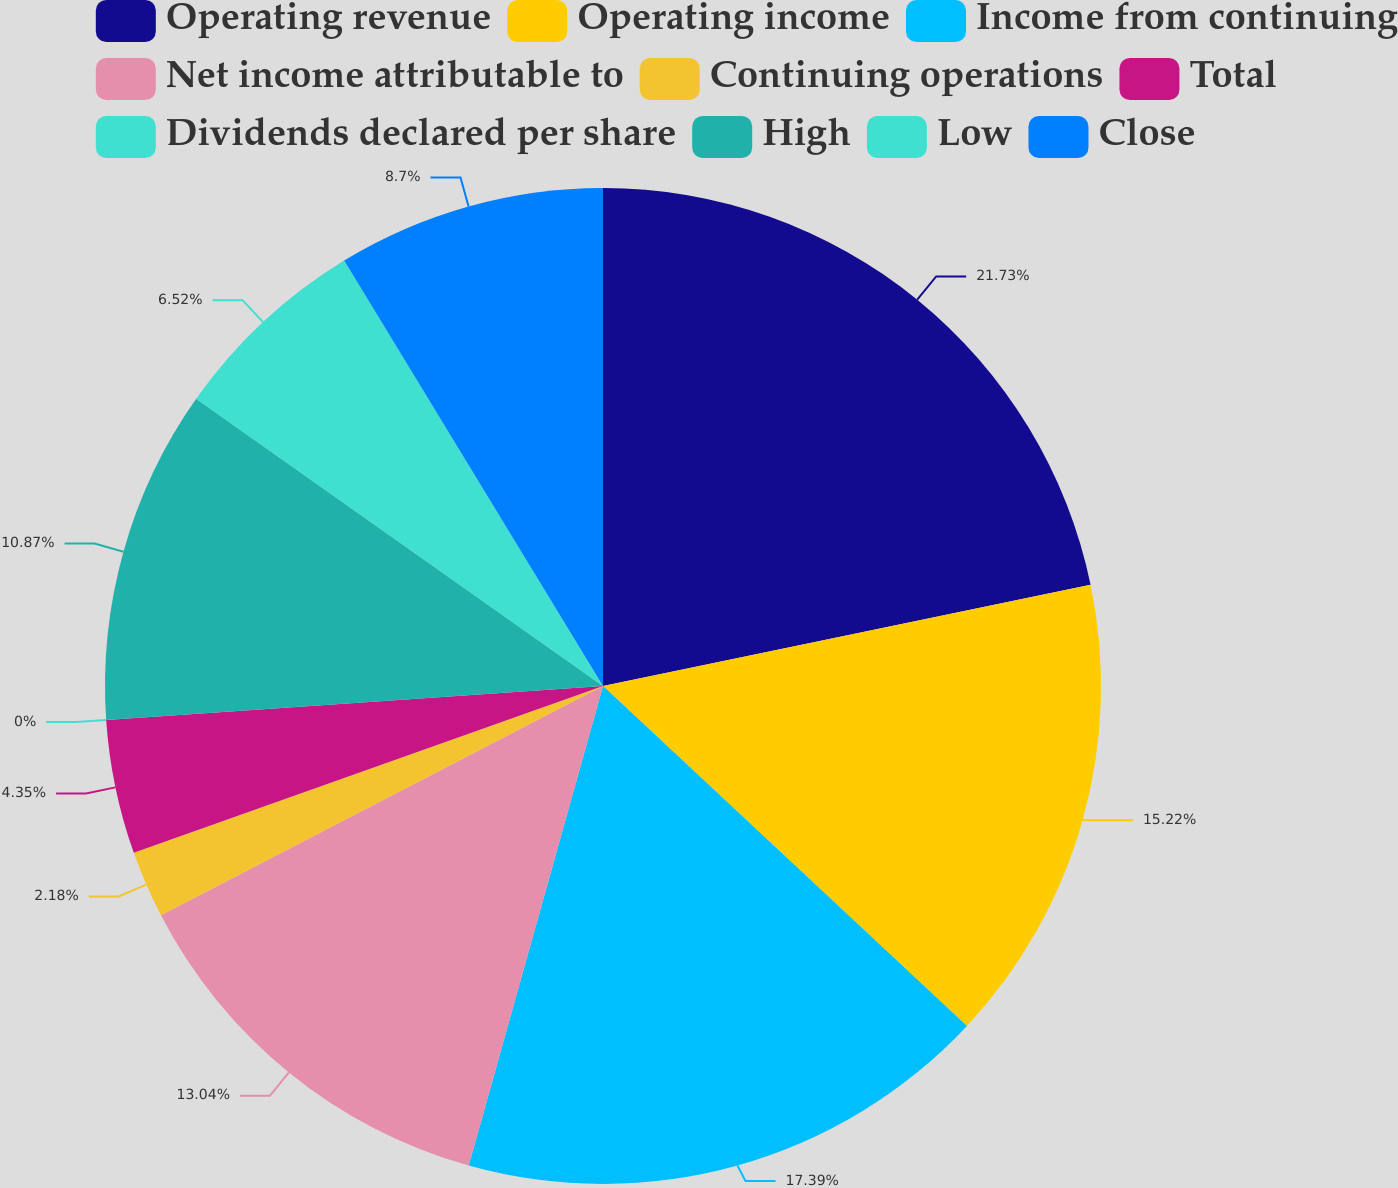Convert chart to OTSL. <chart><loc_0><loc_0><loc_500><loc_500><pie_chart><fcel>Operating revenue<fcel>Operating income<fcel>Income from continuing<fcel>Net income attributable to<fcel>Continuing operations<fcel>Total<fcel>Dividends declared per share<fcel>High<fcel>Low<fcel>Close<nl><fcel>21.74%<fcel>15.22%<fcel>17.39%<fcel>13.04%<fcel>2.18%<fcel>4.35%<fcel>0.0%<fcel>10.87%<fcel>6.52%<fcel>8.7%<nl></chart> 